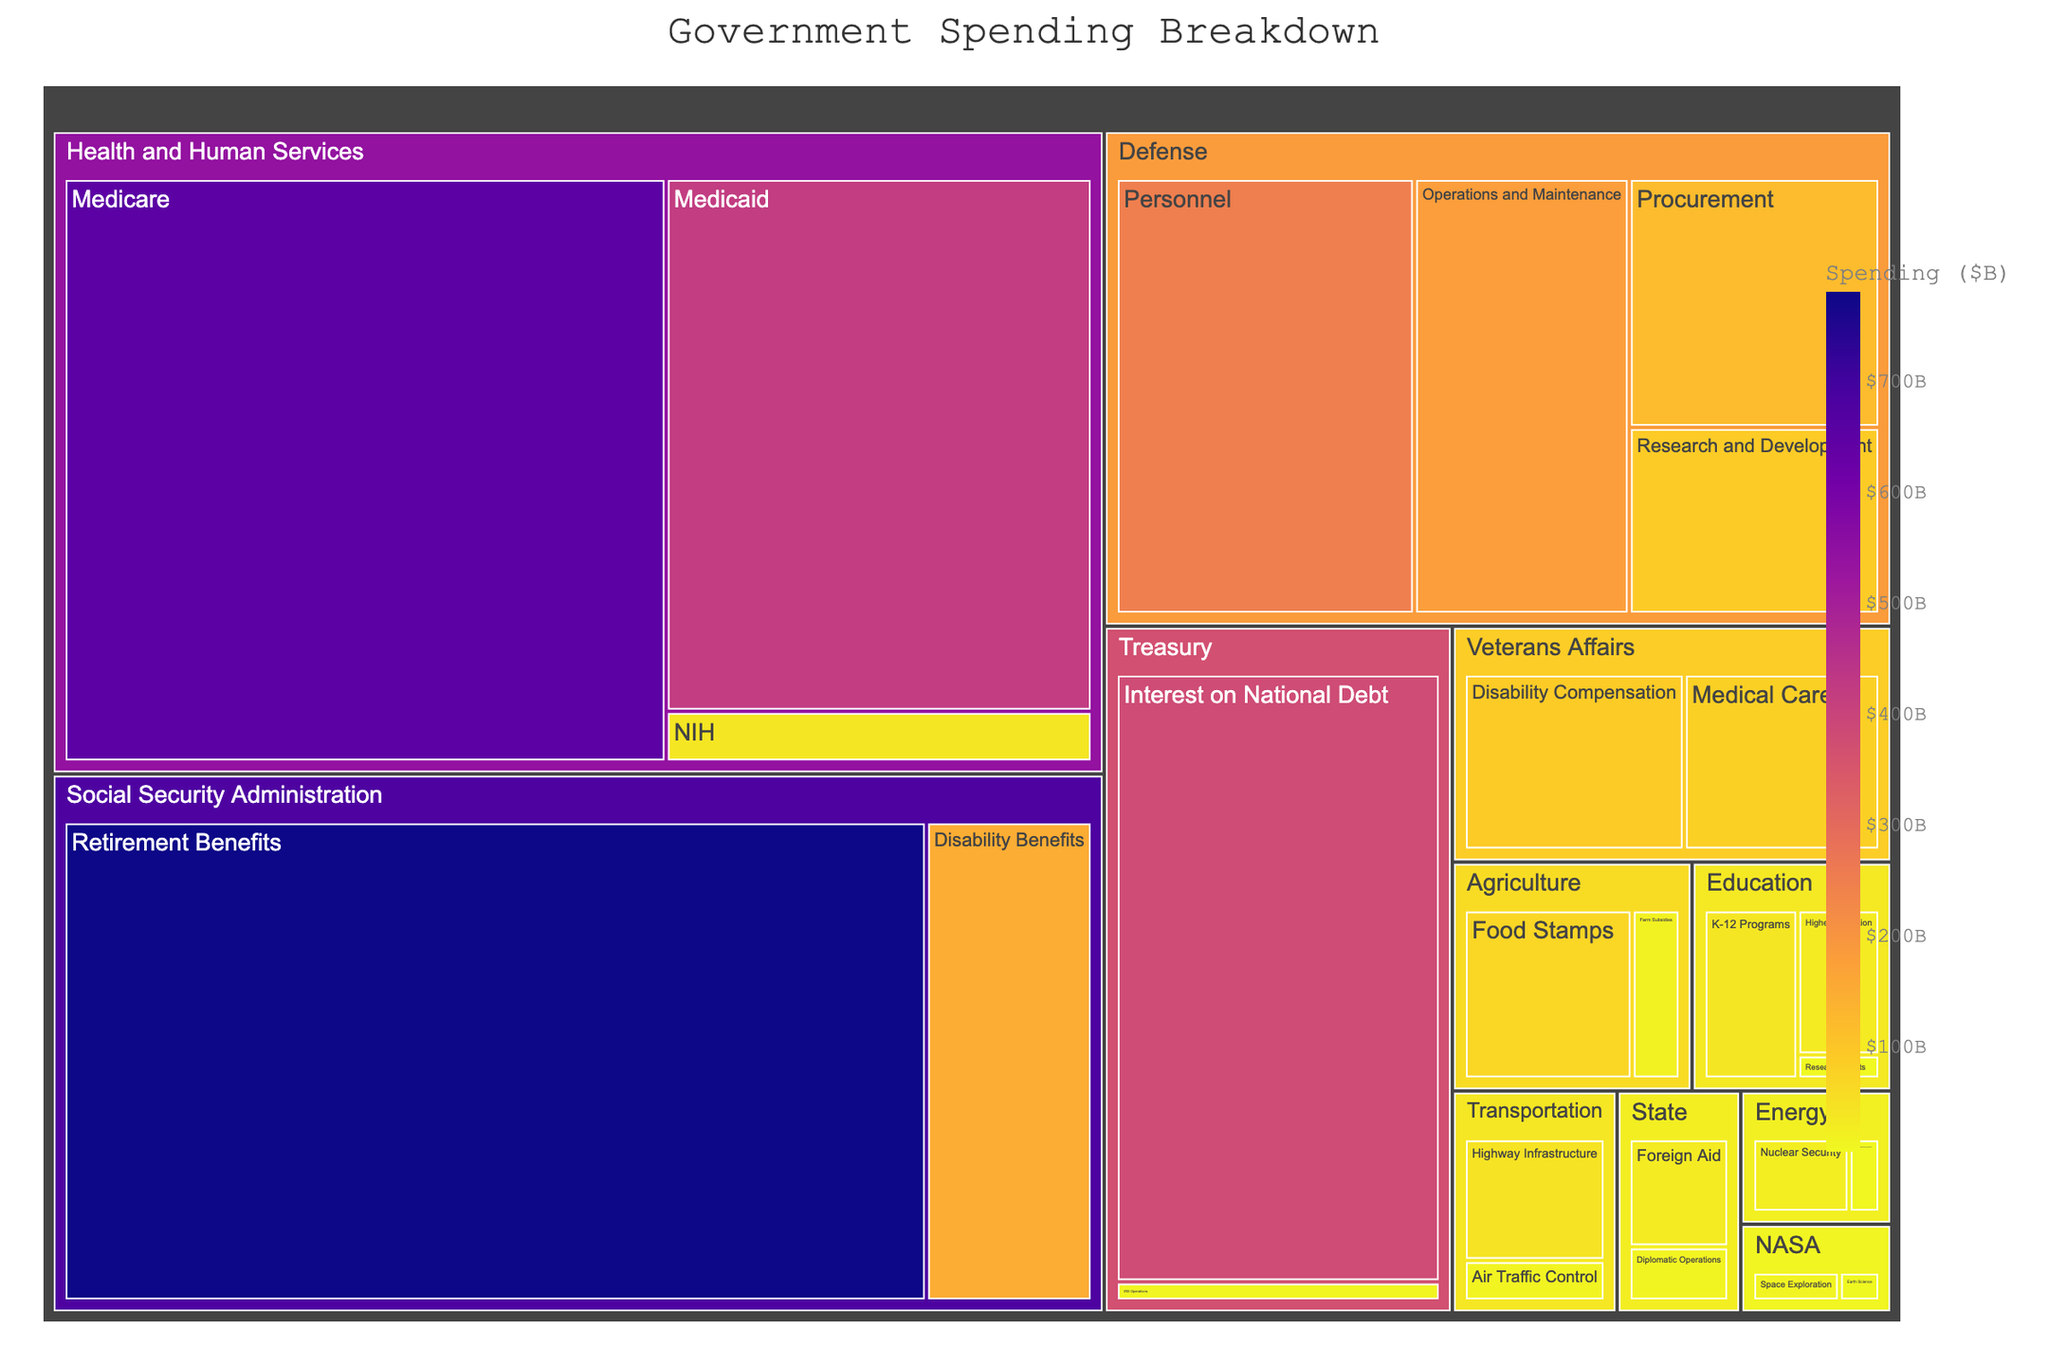How much is the total spending in the Defense department? To find the total spending in the Defense department, add up the spending for each sub-department: 250 (Personnel) + 180 (Operations and Maintenance) + 120 (Procurement) + 90 (Research and Development).
Answer: 640 What department has the maximum spending, and what is that amount? By looking at the size of the segments, the Social Security Administration has the largest segment with 780 for Retirement Benefits.
Answer: Social Security Administration, 780 What sub-department has the smallest spending, and what is that amount? By observing the smallest segment, the Education department’s Research Grants has the smallest spending of 5.
Answer: Research Grants, 5 Which department has more spending: Treasury or Veterans Affairs? By comparing the two departments' segments, Treasury has segments of 380 (Interest on National Debt) + 12 (IRS Operations) = 392, and Veterans Affairs has 80 (Medical Care) + 90 (Disability Compensation) = 170.
Answer: Treasury What is the spending ratio between Medicare and Medicaid in the Health and Human Services department? Divide the Medicare spending by Medicaid spending: 650 / 420.
Answer: 1.55 What is the combined spending for K-12 Programs and Higher Education in the Education department? Add the spending on K-12 Programs and Higher Education: 40 (K-12 Programs) + 30 (Higher Education).
Answer: 70 Which sub-department in Defense has the second-highest spending? After Personnel (250), the next highest spending in Defense is Operations and Maintenance with 180.
Answer: Operations and Maintenance What is the total spending on NASA? Add the spending on NASA’s sub-departments: 15 (Space Exploration) + 7 (Earth Science).
Answer: 22 How does the spending on Renewable Energy Research in the Energy department compare to Diplomatic Operations in the State department? Renewable Energy Research (8) is less than Diplomatic Operations (15).
Answer: Diplomatic Operations has more Identify the department with the largest number of sub-departments and name them. Count the sub-departments for each department; the Education department has three sub-departments: K-12 Programs, Higher Education, and Research Grants.
Answer: Education, K-12 Programs, Higher Education, Research Grants 